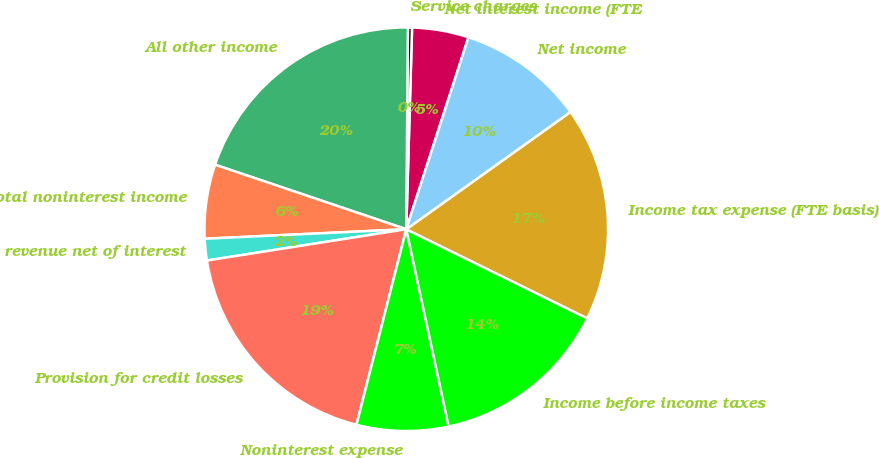Convert chart. <chart><loc_0><loc_0><loc_500><loc_500><pie_chart><fcel>Net interest income (FTE<fcel>Service charges<fcel>All other income<fcel>Total noninterest income<fcel>Total revenue net of interest<fcel>Provision for credit losses<fcel>Noninterest expense<fcel>Income before income taxes<fcel>Income tax expense (FTE basis)<fcel>Net income<nl><fcel>4.53%<fcel>0.33%<fcel>19.95%<fcel>5.93%<fcel>1.73%<fcel>18.55%<fcel>7.34%<fcel>14.35%<fcel>17.15%<fcel>10.14%<nl></chart> 